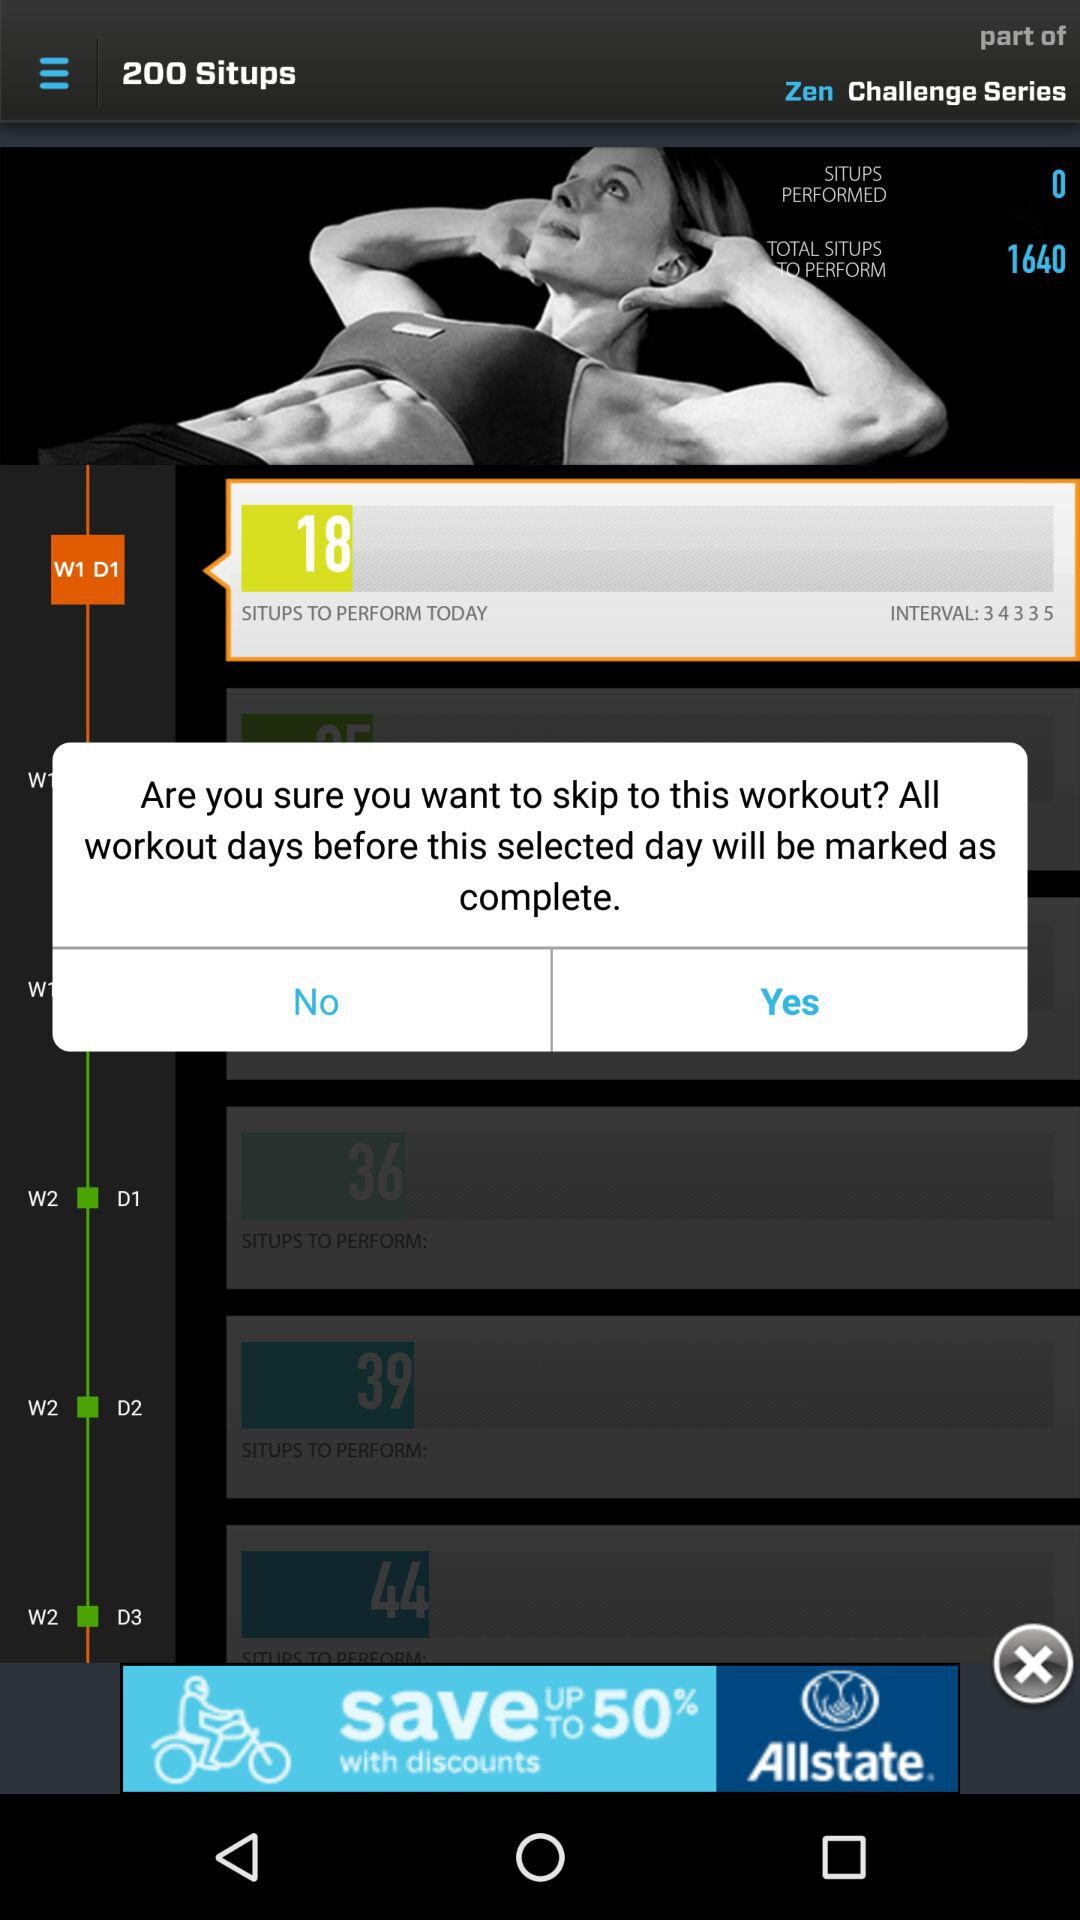What is the count of sit-ups on W2 D3? The count of sit-ups on W2 D3 is 44. 